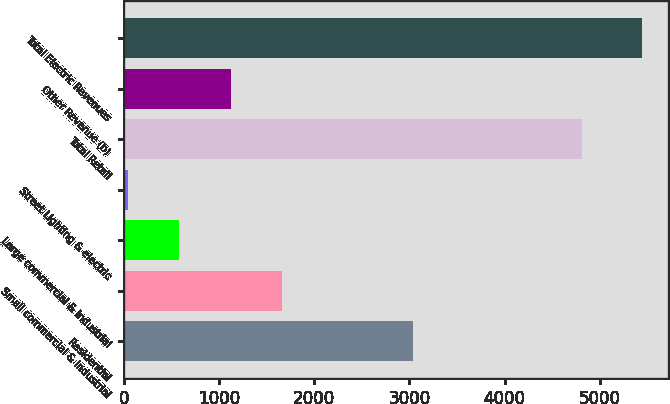<chart> <loc_0><loc_0><loc_500><loc_500><bar_chart><fcel>Residential<fcel>Small commercial & industrial<fcel>Large commercial & industrial<fcel>Street Lighting & electric<fcel>Total Retail<fcel>Other Revenue (b)<fcel>Total Electric Revenues<nl><fcel>3037<fcel>1663.7<fcel>583.9<fcel>44<fcel>4815<fcel>1123.8<fcel>5443<nl></chart> 